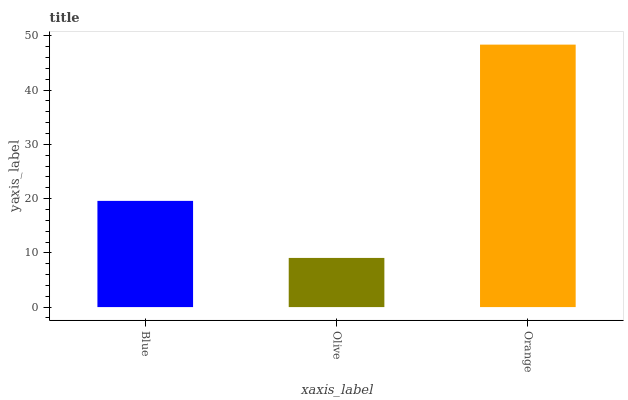Is Olive the minimum?
Answer yes or no. Yes. Is Orange the maximum?
Answer yes or no. Yes. Is Orange the minimum?
Answer yes or no. No. Is Olive the maximum?
Answer yes or no. No. Is Orange greater than Olive?
Answer yes or no. Yes. Is Olive less than Orange?
Answer yes or no. Yes. Is Olive greater than Orange?
Answer yes or no. No. Is Orange less than Olive?
Answer yes or no. No. Is Blue the high median?
Answer yes or no. Yes. Is Blue the low median?
Answer yes or no. Yes. Is Orange the high median?
Answer yes or no. No. Is Olive the low median?
Answer yes or no. No. 